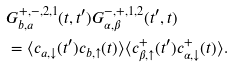<formula> <loc_0><loc_0><loc_500><loc_500>& G ^ { + , - , 2 , 1 } _ { b , a } ( t , t ^ { \prime } ) G ^ { - , + , 1 , 2 } _ { \alpha , \beta } ( t ^ { \prime } , t ) \\ & = \langle c _ { a , \downarrow } ( t ^ { \prime } ) c _ { b , \uparrow } ( t ) \rangle \langle c _ { \beta , \uparrow } ^ { + } ( t ^ { \prime } ) c _ { \alpha , \downarrow } ^ { + } ( t ) \rangle .</formula> 